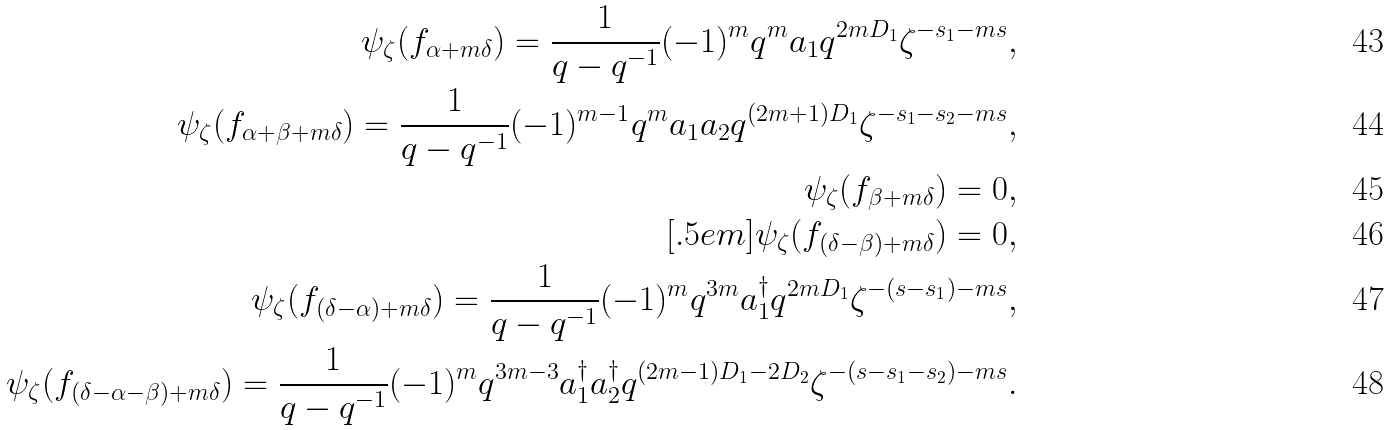Convert formula to latex. <formula><loc_0><loc_0><loc_500><loc_500>\psi _ { \zeta } ( f _ { \alpha + m \delta } ) = \frac { 1 } { q - q ^ { - 1 } } ( - 1 ) ^ { m } q ^ { m } a _ { 1 } q ^ { 2 m D _ { 1 } } \zeta ^ { - s _ { 1 } - m s } , \\ \psi _ { \zeta } ( f _ { \alpha + \beta + m \delta } ) = \frac { 1 } { q - q ^ { - 1 } } ( - 1 ) ^ { m - 1 } q ^ { m } a _ { 1 } a _ { 2 } q ^ { ( 2 m + 1 ) D _ { 1 } } \zeta ^ { - s _ { 1 } - s _ { 2 } - m s } , \\ \psi _ { \zeta } ( f _ { \beta + m \delta } ) = 0 , \\ [ . 5 e m ] \psi _ { \zeta } ( f _ { ( \delta - \beta ) + m \delta } ) = 0 , \\ \psi _ { \zeta } ( f _ { ( \delta - \alpha ) + m \delta } ) = \frac { 1 } { q - q ^ { - 1 } } ( - 1 ) ^ { m } q ^ { 3 m } a _ { 1 } ^ { \dagger } q ^ { 2 m D _ { 1 } } \zeta ^ { - ( s - s _ { 1 } ) - m s } , \\ \psi _ { \zeta } ( f _ { ( \delta - \alpha - \beta ) + m \delta } ) = \frac { 1 } { q - q ^ { - 1 } } ( - 1 ) ^ { m } q ^ { 3 m - 3 } a _ { 1 } ^ { \dagger } a _ { 2 } ^ { \dagger } q ^ { ( 2 m - 1 ) D _ { 1 } - 2 D _ { 2 } } \zeta ^ { - ( s - s _ { 1 } - s _ { 2 } ) - m s } .</formula> 